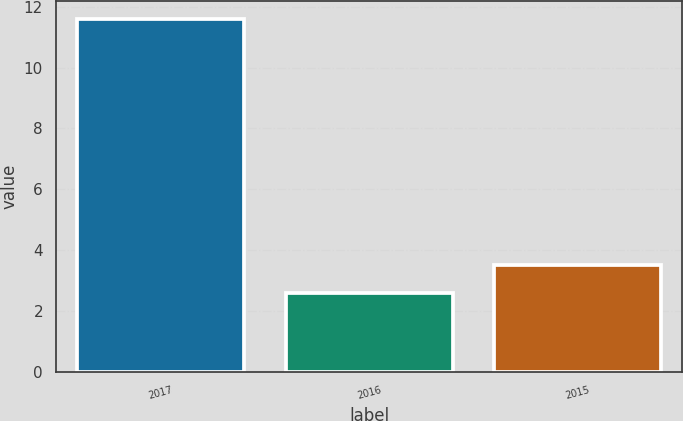Convert chart. <chart><loc_0><loc_0><loc_500><loc_500><bar_chart><fcel>2017<fcel>2016<fcel>2015<nl><fcel>11.6<fcel>2.6<fcel>3.5<nl></chart> 